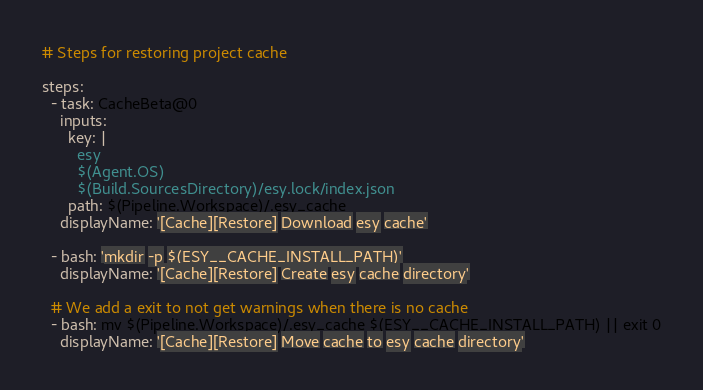<code> <loc_0><loc_0><loc_500><loc_500><_YAML_># Steps for restoring project cache

steps:
  - task: CacheBeta@0
    inputs:
      key: |
        esy
        $(Agent.OS)
        $(Build.SourcesDirectory)/esy.lock/index.json
      path: $(Pipeline.Workspace)/.esy_cache
    displayName: '[Cache][Restore] Download esy cache'

  - bash: 'mkdir -p $(ESY__CACHE_INSTALL_PATH)'
    displayName: '[Cache][Restore] Create esy cache directory'

  # We add a exit to not get warnings when there is no cache
  - bash: mv $(Pipeline.Workspace)/.esy_cache $(ESY__CACHE_INSTALL_PATH) || exit 0
    displayName: '[Cache][Restore] Move cache to esy cache directory'

</code> 